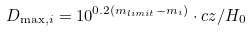Convert formula to latex. <formula><loc_0><loc_0><loc_500><loc_500>D _ { \max , i } = 1 0 ^ { 0 . 2 ( m _ { l i m i t } - m _ { i } ) } \cdot c z / H _ { 0 }</formula> 